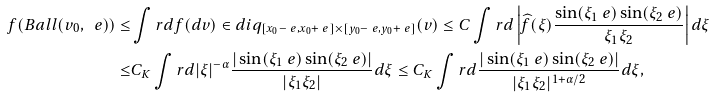Convert formula to latex. <formula><loc_0><loc_0><loc_500><loc_500>f ( B a l l ( v _ { 0 } , \ e ) ) \leq & \int r d f ( d v ) \in d i q _ { [ x _ { 0 } - \ e , x _ { 0 } + \ e ] \times [ y _ { 0 } - \ e , y _ { 0 } + \ e ] } ( v ) \leq C \int r d \left | \widehat { f } ( \xi ) \frac { \sin ( \xi _ { 1 } \ e ) \sin ( \xi _ { 2 } \ e ) } { \xi _ { 1 } \xi _ { 2 } } \right | d \xi \\ \leq & C _ { K } \int r d | \xi | ^ { - \alpha } \frac { | \sin ( \xi _ { 1 } \ e ) \sin ( \xi _ { 2 } \ e ) | } { | \xi _ { 1 } \xi _ { 2 } | } d \xi \leq C _ { K } \int r d \frac { | \sin ( \xi _ { 1 } \ e ) \sin ( \xi _ { 2 } \ e ) | } { | \xi _ { 1 } \xi _ { 2 } | ^ { 1 + \alpha / 2 } } d \xi ,</formula> 